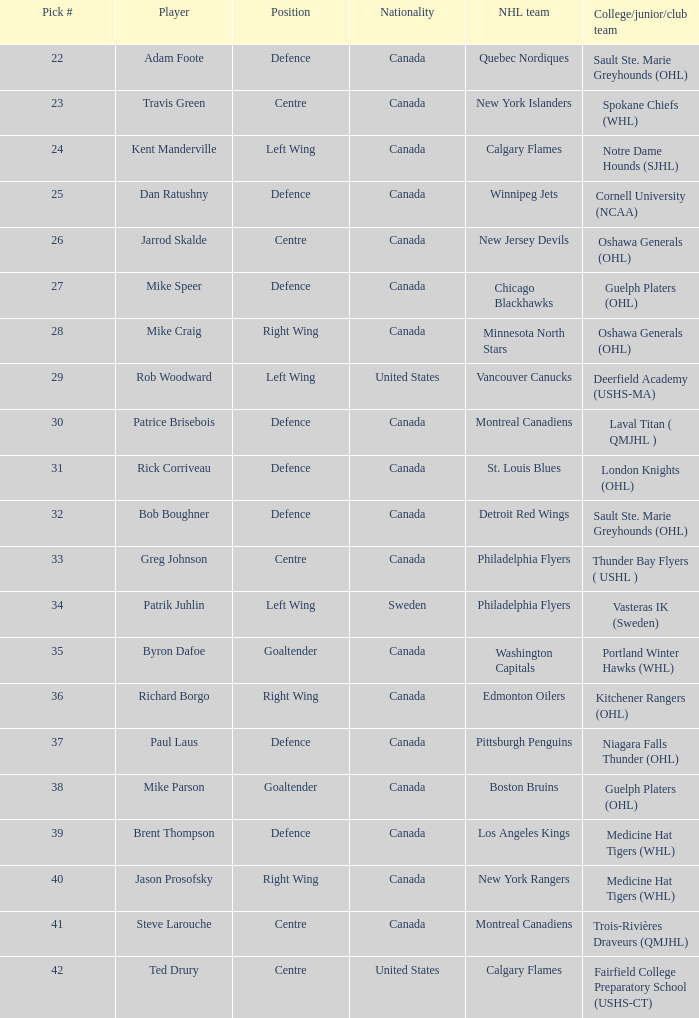What is the citizenship of the draft pick athlete who plays the center role and is joining the calgary flames? United States. 